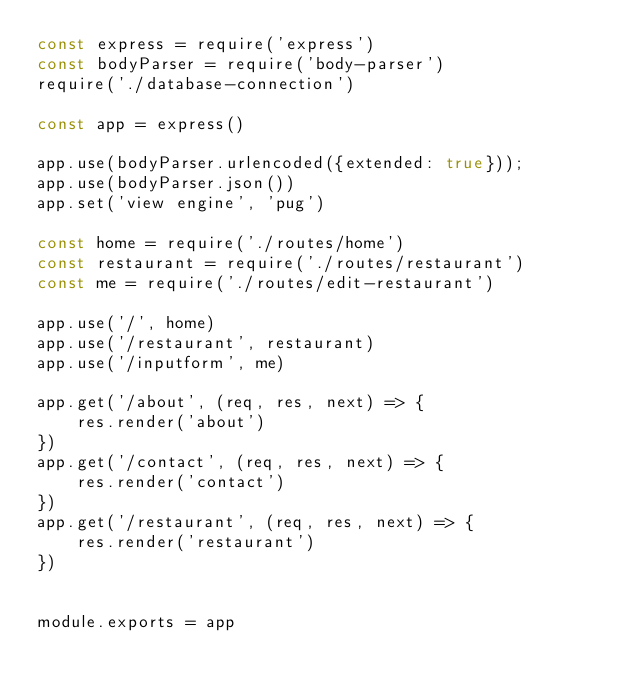Convert code to text. <code><loc_0><loc_0><loc_500><loc_500><_JavaScript_>const express = require('express')
const bodyParser = require('body-parser')
require('./database-connection')

const app = express()

app.use(bodyParser.urlencoded({extended: true}));
app.use(bodyParser.json())
app.set('view engine', 'pug')

const home = require('./routes/home')
const restaurant = require('./routes/restaurant')
const me = require('./routes/edit-restaurant')

app.use('/', home)
app.use('/restaurant', restaurant)
app.use('/inputform', me)

app.get('/about', (req, res, next) => {
    res.render('about')
})
app.get('/contact', (req, res, next) => {
    res.render('contact')
})
app.get('/restaurant', (req, res, next) => {
    res.render('restaurant')
})


module.exports = app
</code> 